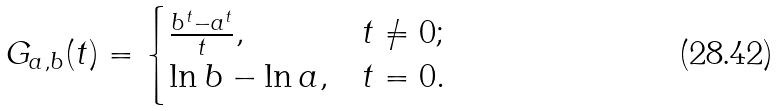<formula> <loc_0><loc_0><loc_500><loc_500>G _ { a , b } ( t ) = \begin{cases} \frac { b ^ { t } - a ^ { t } } { t } , & t \neq 0 ; \\ \ln b - \ln a , & t = 0 . \end{cases}</formula> 